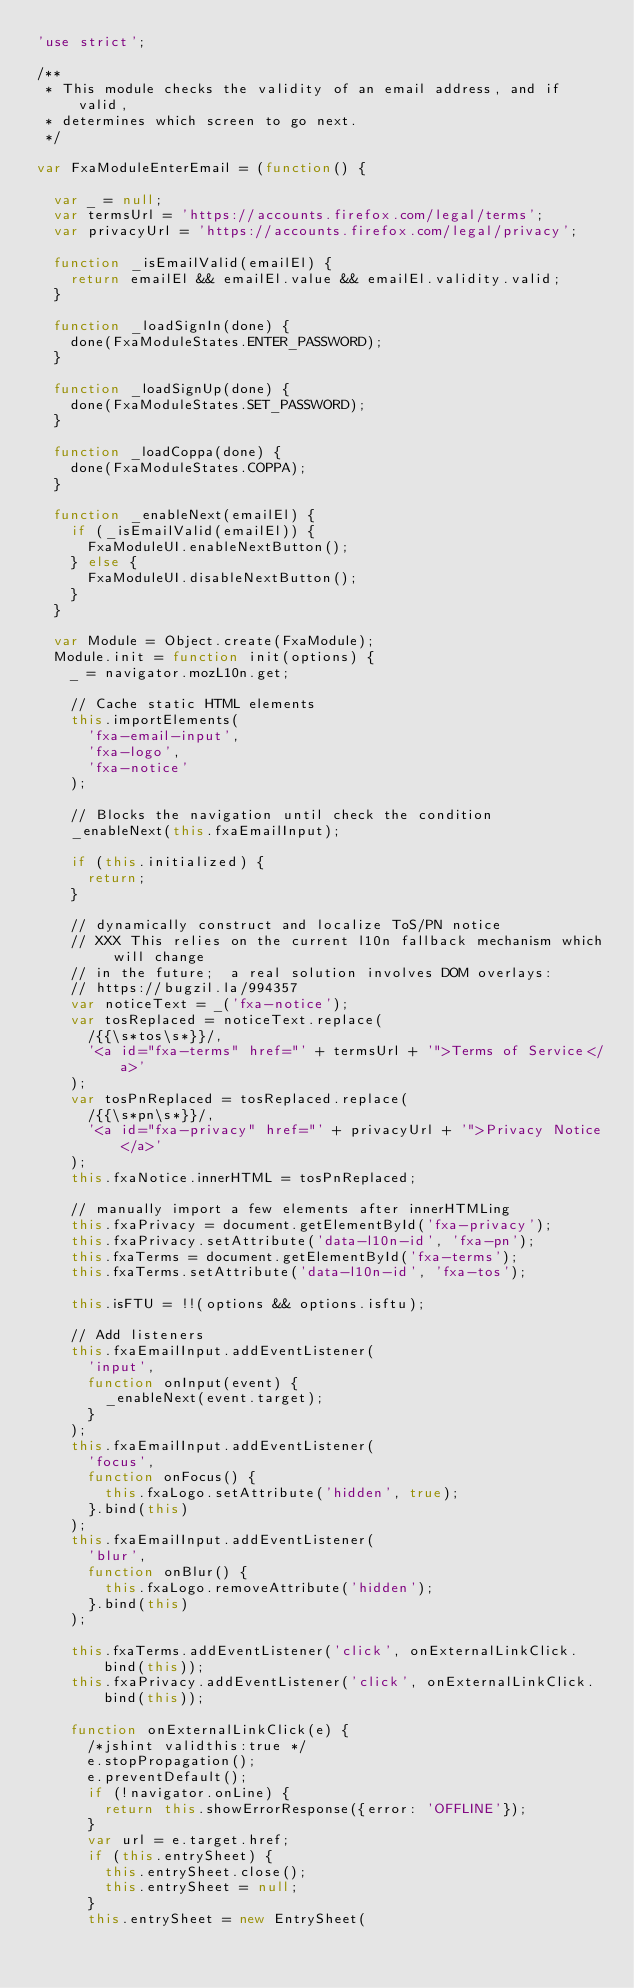Convert code to text. <code><loc_0><loc_0><loc_500><loc_500><_JavaScript_>'use strict';

/**
 * This module checks the validity of an email address, and if valid,
 * determines which screen to go next.
 */

var FxaModuleEnterEmail = (function() {

  var _ = null;
  var termsUrl = 'https://accounts.firefox.com/legal/terms';
  var privacyUrl = 'https://accounts.firefox.com/legal/privacy';

  function _isEmailValid(emailEl) {
    return emailEl && emailEl.value && emailEl.validity.valid;
  }

  function _loadSignIn(done) {
    done(FxaModuleStates.ENTER_PASSWORD);
  }

  function _loadSignUp(done) {
    done(FxaModuleStates.SET_PASSWORD);
  }

  function _loadCoppa(done) {
    done(FxaModuleStates.COPPA);
  }

  function _enableNext(emailEl) {
    if (_isEmailValid(emailEl)) {
      FxaModuleUI.enableNextButton();
    } else {
      FxaModuleUI.disableNextButton();
    }
  }

  var Module = Object.create(FxaModule);
  Module.init = function init(options) {
    _ = navigator.mozL10n.get;

    // Cache static HTML elements
    this.importElements(
      'fxa-email-input',
      'fxa-logo',
      'fxa-notice'
    );

    // Blocks the navigation until check the condition
    _enableNext(this.fxaEmailInput);

    if (this.initialized) {
      return;
    }

    // dynamically construct and localize ToS/PN notice
    // XXX This relies on the current l10n fallback mechanism which will change
    // in the future;  a real solution involves DOM overlays:
    // https://bugzil.la/994357
    var noticeText = _('fxa-notice');
    var tosReplaced = noticeText.replace(
      /{{\s*tos\s*}}/,
      '<a id="fxa-terms" href="' + termsUrl + '">Terms of Service</a>'
    );
    var tosPnReplaced = tosReplaced.replace(
      /{{\s*pn\s*}}/,
      '<a id="fxa-privacy" href="' + privacyUrl + '">Privacy Notice</a>'
    );
    this.fxaNotice.innerHTML = tosPnReplaced;

    // manually import a few elements after innerHTMLing
    this.fxaPrivacy = document.getElementById('fxa-privacy');
    this.fxaPrivacy.setAttribute('data-l10n-id', 'fxa-pn');
    this.fxaTerms = document.getElementById('fxa-terms');
    this.fxaTerms.setAttribute('data-l10n-id', 'fxa-tos');

    this.isFTU = !!(options && options.isftu);

    // Add listeners
    this.fxaEmailInput.addEventListener(
      'input',
      function onInput(event) {
        _enableNext(event.target);
      }
    );
    this.fxaEmailInput.addEventListener(
      'focus',
      function onFocus() {
        this.fxaLogo.setAttribute('hidden', true);
      }.bind(this)
    );
    this.fxaEmailInput.addEventListener(
      'blur',
      function onBlur() {
        this.fxaLogo.removeAttribute('hidden');
      }.bind(this)
    );

    this.fxaTerms.addEventListener('click', onExternalLinkClick.bind(this));
    this.fxaPrivacy.addEventListener('click', onExternalLinkClick.bind(this));

    function onExternalLinkClick(e) {
      /*jshint validthis:true */
      e.stopPropagation();
      e.preventDefault();
      if (!navigator.onLine) {
        return this.showErrorResponse({error: 'OFFLINE'});
      }
      var url = e.target.href;
      if (this.entrySheet) {
        this.entrySheet.close();
        this.entrySheet = null;
      }
      this.entrySheet = new EntrySheet(</code> 